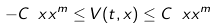Convert formula to latex. <formula><loc_0><loc_0><loc_500><loc_500>- C \ x x ^ { m } \leq V ( t , x ) \leq C \ x x ^ { m }</formula> 